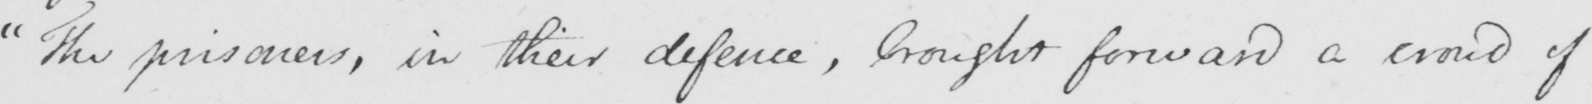What text is written in this handwritten line? " The prisoners , in their defence , brought forward a crowd of 